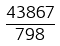Convert formula to latex. <formula><loc_0><loc_0><loc_500><loc_500>\frac { 4 3 8 6 7 } { 7 9 8 }</formula> 